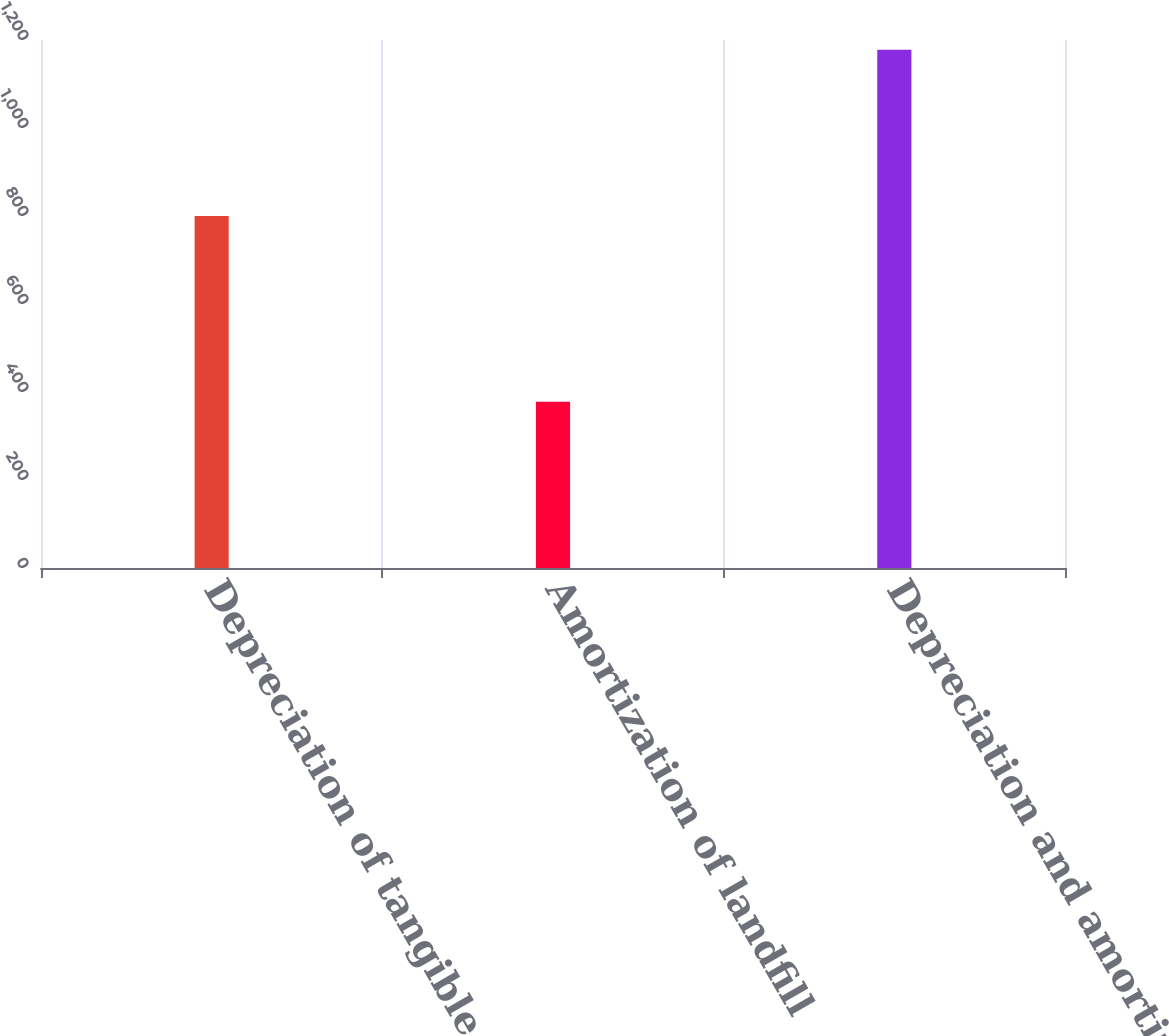<chart> <loc_0><loc_0><loc_500><loc_500><bar_chart><fcel>Depreciation of tangible<fcel>Amortization of landfill<fcel>Depreciation and amortization<nl><fcel>800<fcel>378<fcel>1178<nl></chart> 